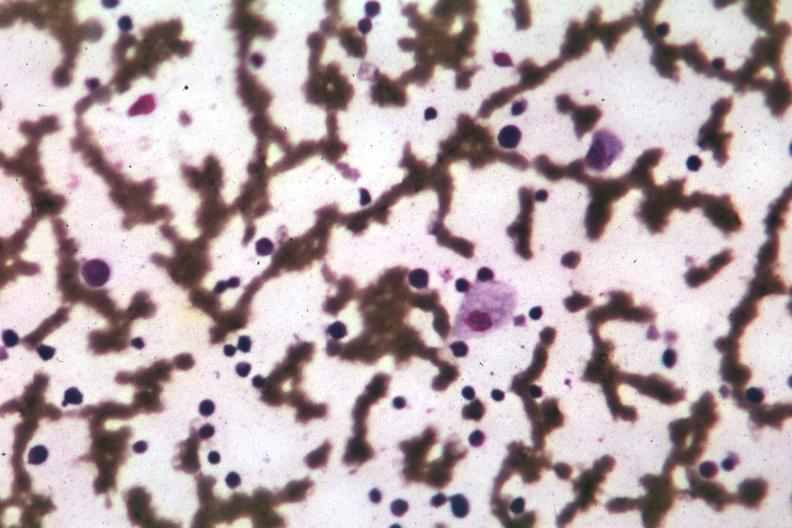s amebiasis present?
Answer the question using a single word or phrase. No 